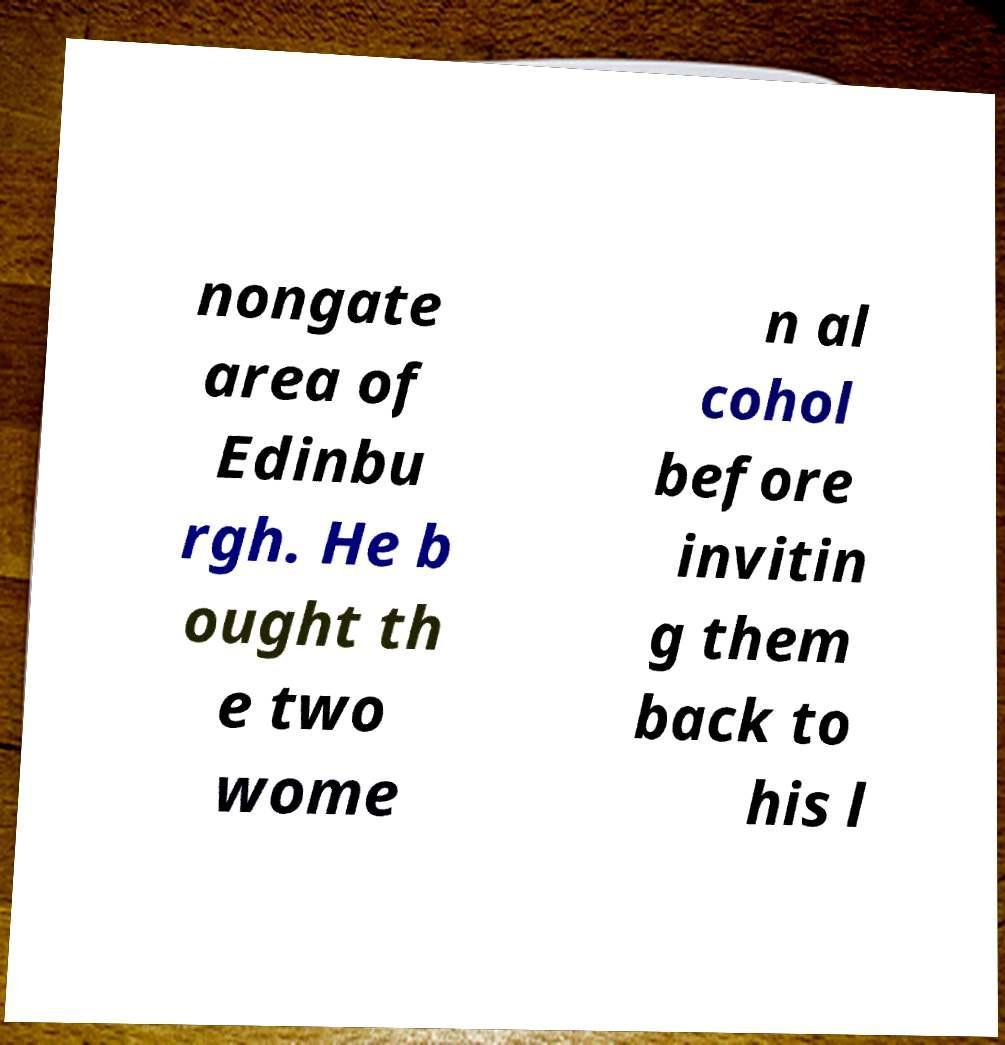Could you extract and type out the text from this image? nongate area of Edinbu rgh. He b ought th e two wome n al cohol before invitin g them back to his l 